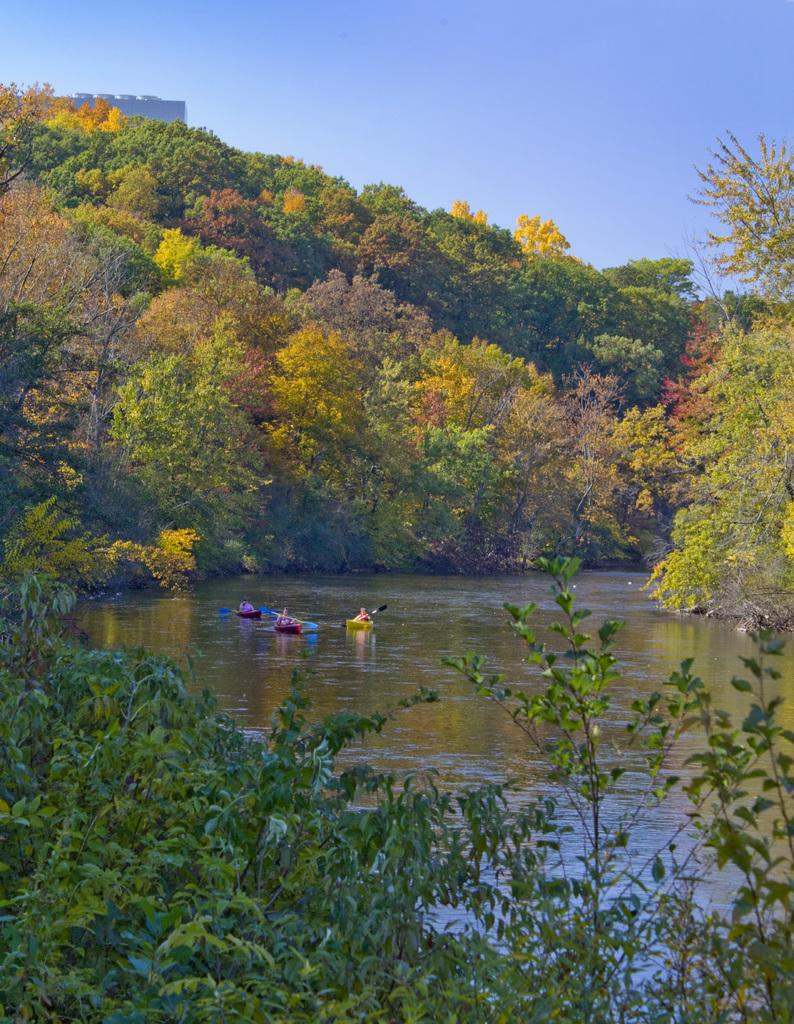How many boats can be seen in the water in the image? There are three boats in the water in the image. Where are the boats located in the image? The boats are in the center of the image. What can be seen in the background of the image? There is a group of trees and the sky visible in the background. What is the size of the moon in the image? There is no moon present in the image. What does the group of trees feel in the image? Trees do not have feelings, so it is not possible to determine what they might feel in the image. 